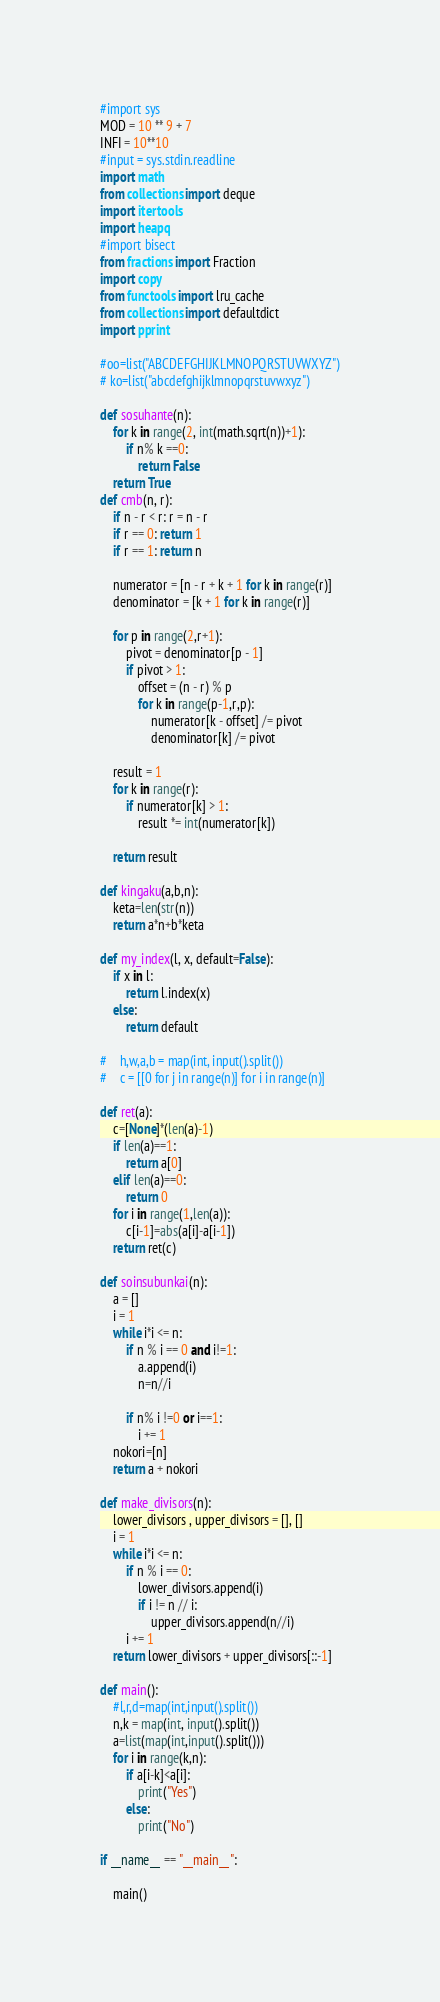Convert code to text. <code><loc_0><loc_0><loc_500><loc_500><_Python_>#import sys
MOD = 10 ** 9 + 7
INFI = 10**10
#input = sys.stdin.readline
import math
from collections import deque
import itertools
import heapq
#import bisect
from fractions import Fraction
import copy
from functools import lru_cache
from collections import defaultdict
import pprint

#oo=list("ABCDEFGHIJKLMNOPQRSTUVWXYZ")
# ko=list("abcdefghijklmnopqrstuvwxyz")

def sosuhante(n):
    for k in range(2, int(math.sqrt(n))+1):
        if n% k ==0:
            return False
    return True
def cmb(n, r):
    if n - r < r: r = n - r
    if r == 0: return 1
    if r == 1: return n

    numerator = [n - r + k + 1 for k in range(r)]
    denominator = [k + 1 for k in range(r)]

    for p in range(2,r+1):
        pivot = denominator[p - 1]
        if pivot > 1:
            offset = (n - r) % p
            for k in range(p-1,r,p):
                numerator[k - offset] /= pivot
                denominator[k] /= pivot

    result = 1
    for k in range(r):
        if numerator[k] > 1:
            result *= int(numerator[k])

    return result

def kingaku(a,b,n):
    keta=len(str(n))
    return a*n+b*keta

def my_index(l, x, default=False):
    if x in l:
        return l.index(x)
    else:
        return default

#    h,w,a,b = map(int, input().split())
#    c = [[0 for j in range(n)] for i in range(n)]

def ret(a):
    c=[None]*(len(a)-1)
    if len(a)==1:
        return a[0]
    elif len(a)==0:
        return 0
    for i in range(1,len(a)):
        c[i-1]=abs(a[i]-a[i-1])
    return ret(c)

def soinsubunkai(n):
    a = []
    i = 1
    while i*i <= n:
        if n % i == 0 and i!=1:
            a.append(i)
            n=n//i

        if n% i !=0 or i==1:
            i += 1
    nokori=[n]
    return a + nokori

def make_divisors(n):
    lower_divisors , upper_divisors = [], []
    i = 1
    while i*i <= n:
        if n % i == 0:
            lower_divisors.append(i)
            if i != n // i:
                upper_divisors.append(n//i)
        i += 1
    return lower_divisors + upper_divisors[::-1]

def main():
    #l,r,d=map(int,input().split())
    n,k = map(int, input().split())
    a=list(map(int,input().split()))
    for i in range(k,n):
        if a[i-k]<a[i]:
            print("Yes")
        else:
            print("No")

if __name__ == "__main__":

    main()
</code> 